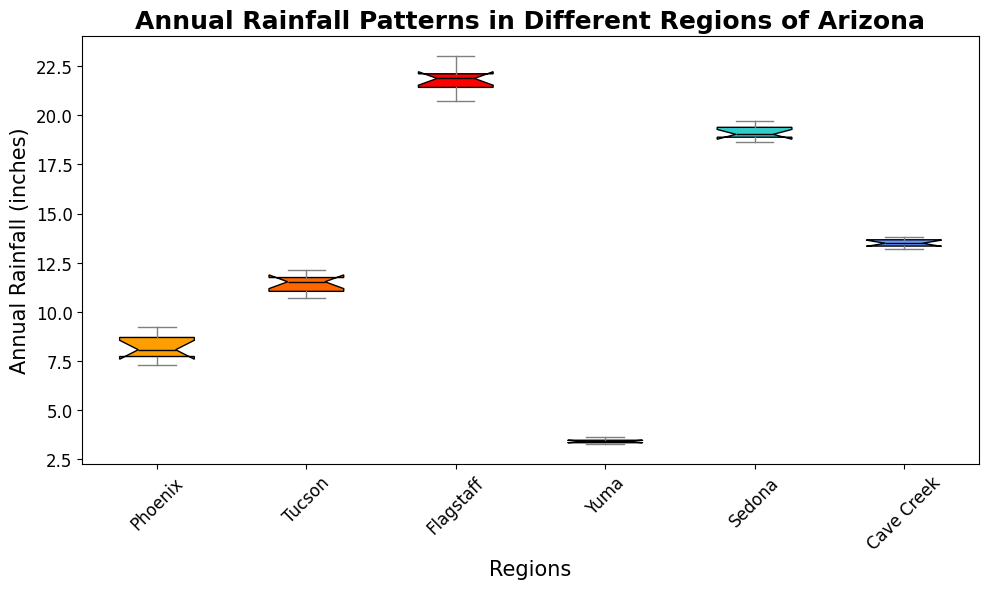What's the median annual rainfall for Phoenix? Identify the box plot for Phoenix and locate the median line within the box. The median is represented by the black line inside the box.
Answer: 8.10 inches Which region has the highest median annual rainfall? Compare the median lines within the boxes for all the regions and identify the tallest median. The highest median line corresponds to the region with the highest median annual rainfall.
Answer: Flagstaff Which region shows the least variability in annual rainfall? Observe the width of each box plot's interquartile range (IQR). The region with the narrowest IQR has the least variability.
Answer: Yuma What is the interquartile range (IQR) for Sedona? Identify the Sedona box plot and note the values at the top (third quartile) and bottom (first quartile) of the box. Subtract the first quartile from the third quartile to get the IQR.
Answer: 0.93 inches Compare the annual rainfall spread between Tucson and Cave Creek. Which region shows a larger spread? Examine the combined length of the whiskers for Tucson and Cave Creek and determine which is longer. The region with longer whiskers has a larger spread.
Answer: Tucson For which region does the median lie closest to the top of the box? Look at the positioning of the black median lines within the boxes for all regions. The region where the median is closest to the third quartile (top line of the box) is the answer.
Answer: Yuma How does the median rainfall in Cave Creek compare to the median rainfall in Tucson? Compare the black median lines in the boxes for Cave Creek and Tucson and determine which is higher.
Answer: Tucson has a higher median rainfall What is the difference between the maximum rainfall in Flagstaff and the maximum rainfall in Yuma? Identify the top whisker values for Flagstaff and Yuma. Subtract the maximum value for Yuma from the maximum value for Flagstaff to get the difference.
Answer: 19.67 inches Which region has the lowest minimum rainfall? Look at the bottom whiskers for all regions and note the lowest point among them.
Answer: Yuma 